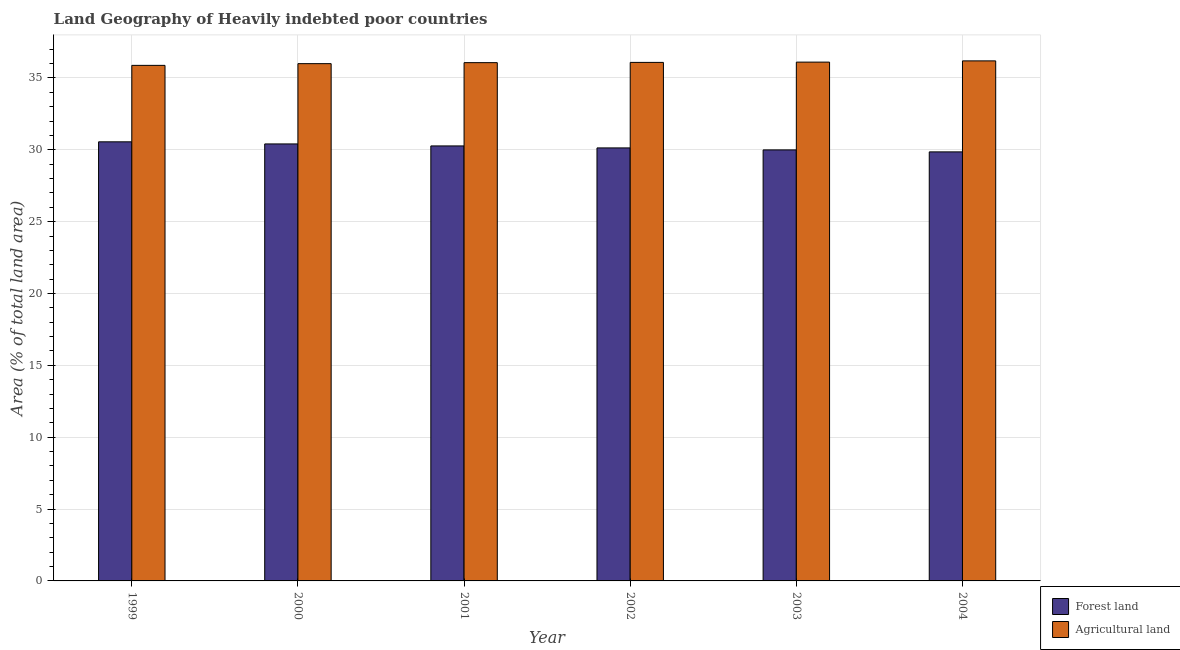How many groups of bars are there?
Keep it short and to the point. 6. Are the number of bars per tick equal to the number of legend labels?
Your answer should be compact. Yes. How many bars are there on the 2nd tick from the left?
Your answer should be very brief. 2. How many bars are there on the 5th tick from the right?
Provide a short and direct response. 2. What is the label of the 6th group of bars from the left?
Provide a succinct answer. 2004. In how many cases, is the number of bars for a given year not equal to the number of legend labels?
Provide a short and direct response. 0. What is the percentage of land area under forests in 2003?
Provide a succinct answer. 29.99. Across all years, what is the maximum percentage of land area under agriculture?
Provide a short and direct response. 36.19. Across all years, what is the minimum percentage of land area under agriculture?
Your answer should be compact. 35.87. In which year was the percentage of land area under agriculture maximum?
Ensure brevity in your answer.  2004. What is the total percentage of land area under agriculture in the graph?
Keep it short and to the point. 216.3. What is the difference between the percentage of land area under forests in 2000 and that in 2002?
Provide a succinct answer. 0.28. What is the difference between the percentage of land area under agriculture in 2001 and the percentage of land area under forests in 2000?
Make the answer very short. 0.07. What is the average percentage of land area under agriculture per year?
Make the answer very short. 36.05. In the year 2003, what is the difference between the percentage of land area under agriculture and percentage of land area under forests?
Your answer should be compact. 0. In how many years, is the percentage of land area under forests greater than 22 %?
Provide a succinct answer. 6. What is the ratio of the percentage of land area under forests in 2001 to that in 2002?
Ensure brevity in your answer.  1. Is the percentage of land area under agriculture in 1999 less than that in 2001?
Offer a terse response. Yes. Is the difference between the percentage of land area under agriculture in 2002 and 2003 greater than the difference between the percentage of land area under forests in 2002 and 2003?
Offer a very short reply. No. What is the difference between the highest and the second highest percentage of land area under forests?
Keep it short and to the point. 0.15. What is the difference between the highest and the lowest percentage of land area under forests?
Offer a very short reply. 0.7. In how many years, is the percentage of land area under agriculture greater than the average percentage of land area under agriculture taken over all years?
Keep it short and to the point. 4. Is the sum of the percentage of land area under agriculture in 1999 and 2002 greater than the maximum percentage of land area under forests across all years?
Provide a succinct answer. Yes. What does the 2nd bar from the left in 1999 represents?
Your answer should be very brief. Agricultural land. What does the 1st bar from the right in 1999 represents?
Offer a very short reply. Agricultural land. How many bars are there?
Make the answer very short. 12. Are all the bars in the graph horizontal?
Make the answer very short. No. What is the difference between two consecutive major ticks on the Y-axis?
Make the answer very short. 5. Are the values on the major ticks of Y-axis written in scientific E-notation?
Your response must be concise. No. What is the title of the graph?
Provide a succinct answer. Land Geography of Heavily indebted poor countries. What is the label or title of the X-axis?
Make the answer very short. Year. What is the label or title of the Y-axis?
Provide a short and direct response. Area (% of total land area). What is the Area (% of total land area) in Forest land in 1999?
Provide a short and direct response. 30.55. What is the Area (% of total land area) of Agricultural land in 1999?
Provide a short and direct response. 35.87. What is the Area (% of total land area) of Forest land in 2000?
Give a very brief answer. 30.41. What is the Area (% of total land area) in Agricultural land in 2000?
Offer a terse response. 35.99. What is the Area (% of total land area) of Forest land in 2001?
Provide a succinct answer. 30.27. What is the Area (% of total land area) in Agricultural land in 2001?
Keep it short and to the point. 36.06. What is the Area (% of total land area) in Forest land in 2002?
Offer a terse response. 30.13. What is the Area (% of total land area) in Agricultural land in 2002?
Your answer should be compact. 36.08. What is the Area (% of total land area) of Forest land in 2003?
Provide a succinct answer. 29.99. What is the Area (% of total land area) of Agricultural land in 2003?
Provide a succinct answer. 36.1. What is the Area (% of total land area) in Forest land in 2004?
Give a very brief answer. 29.85. What is the Area (% of total land area) in Agricultural land in 2004?
Your response must be concise. 36.19. Across all years, what is the maximum Area (% of total land area) in Forest land?
Keep it short and to the point. 30.55. Across all years, what is the maximum Area (% of total land area) in Agricultural land?
Keep it short and to the point. 36.19. Across all years, what is the minimum Area (% of total land area) in Forest land?
Your answer should be compact. 29.85. Across all years, what is the minimum Area (% of total land area) in Agricultural land?
Provide a succinct answer. 35.87. What is the total Area (% of total land area) in Forest land in the graph?
Offer a very short reply. 181.21. What is the total Area (% of total land area) in Agricultural land in the graph?
Your answer should be very brief. 216.3. What is the difference between the Area (% of total land area) in Forest land in 1999 and that in 2000?
Your response must be concise. 0.15. What is the difference between the Area (% of total land area) in Agricultural land in 1999 and that in 2000?
Offer a terse response. -0.12. What is the difference between the Area (% of total land area) of Forest land in 1999 and that in 2001?
Provide a succinct answer. 0.28. What is the difference between the Area (% of total land area) in Agricultural land in 1999 and that in 2001?
Give a very brief answer. -0.19. What is the difference between the Area (% of total land area) in Forest land in 1999 and that in 2002?
Your response must be concise. 0.42. What is the difference between the Area (% of total land area) in Agricultural land in 1999 and that in 2002?
Ensure brevity in your answer.  -0.21. What is the difference between the Area (% of total land area) of Forest land in 1999 and that in 2003?
Provide a succinct answer. 0.56. What is the difference between the Area (% of total land area) in Agricultural land in 1999 and that in 2003?
Provide a short and direct response. -0.23. What is the difference between the Area (% of total land area) of Forest land in 1999 and that in 2004?
Keep it short and to the point. 0.7. What is the difference between the Area (% of total land area) of Agricultural land in 1999 and that in 2004?
Keep it short and to the point. -0.31. What is the difference between the Area (% of total land area) of Forest land in 2000 and that in 2001?
Ensure brevity in your answer.  0.14. What is the difference between the Area (% of total land area) of Agricultural land in 2000 and that in 2001?
Keep it short and to the point. -0.07. What is the difference between the Area (% of total land area) in Forest land in 2000 and that in 2002?
Ensure brevity in your answer.  0.28. What is the difference between the Area (% of total land area) of Agricultural land in 2000 and that in 2002?
Offer a very short reply. -0.09. What is the difference between the Area (% of total land area) of Forest land in 2000 and that in 2003?
Keep it short and to the point. 0.41. What is the difference between the Area (% of total land area) of Agricultural land in 2000 and that in 2003?
Ensure brevity in your answer.  -0.11. What is the difference between the Area (% of total land area) in Forest land in 2000 and that in 2004?
Offer a terse response. 0.55. What is the difference between the Area (% of total land area) in Agricultural land in 2000 and that in 2004?
Keep it short and to the point. -0.19. What is the difference between the Area (% of total land area) of Forest land in 2001 and that in 2002?
Give a very brief answer. 0.14. What is the difference between the Area (% of total land area) in Agricultural land in 2001 and that in 2002?
Ensure brevity in your answer.  -0.02. What is the difference between the Area (% of total land area) in Forest land in 2001 and that in 2003?
Keep it short and to the point. 0.28. What is the difference between the Area (% of total land area) of Agricultural land in 2001 and that in 2003?
Offer a very short reply. -0.04. What is the difference between the Area (% of total land area) in Forest land in 2001 and that in 2004?
Provide a short and direct response. 0.41. What is the difference between the Area (% of total land area) in Agricultural land in 2001 and that in 2004?
Offer a very short reply. -0.12. What is the difference between the Area (% of total land area) in Forest land in 2002 and that in 2003?
Make the answer very short. 0.14. What is the difference between the Area (% of total land area) of Agricultural land in 2002 and that in 2003?
Your answer should be very brief. -0.02. What is the difference between the Area (% of total land area) in Forest land in 2002 and that in 2004?
Ensure brevity in your answer.  0.28. What is the difference between the Area (% of total land area) of Agricultural land in 2002 and that in 2004?
Make the answer very short. -0.11. What is the difference between the Area (% of total land area) in Forest land in 2003 and that in 2004?
Offer a terse response. 0.14. What is the difference between the Area (% of total land area) in Agricultural land in 2003 and that in 2004?
Your answer should be very brief. -0.09. What is the difference between the Area (% of total land area) in Forest land in 1999 and the Area (% of total land area) in Agricultural land in 2000?
Your answer should be compact. -5.44. What is the difference between the Area (% of total land area) in Forest land in 1999 and the Area (% of total land area) in Agricultural land in 2001?
Provide a short and direct response. -5.51. What is the difference between the Area (% of total land area) in Forest land in 1999 and the Area (% of total land area) in Agricultural land in 2002?
Offer a terse response. -5.53. What is the difference between the Area (% of total land area) in Forest land in 1999 and the Area (% of total land area) in Agricultural land in 2003?
Your answer should be compact. -5.55. What is the difference between the Area (% of total land area) in Forest land in 1999 and the Area (% of total land area) in Agricultural land in 2004?
Provide a short and direct response. -5.63. What is the difference between the Area (% of total land area) of Forest land in 2000 and the Area (% of total land area) of Agricultural land in 2001?
Make the answer very short. -5.66. What is the difference between the Area (% of total land area) in Forest land in 2000 and the Area (% of total land area) in Agricultural land in 2002?
Provide a succinct answer. -5.67. What is the difference between the Area (% of total land area) in Forest land in 2000 and the Area (% of total land area) in Agricultural land in 2003?
Your answer should be compact. -5.69. What is the difference between the Area (% of total land area) in Forest land in 2000 and the Area (% of total land area) in Agricultural land in 2004?
Ensure brevity in your answer.  -5.78. What is the difference between the Area (% of total land area) of Forest land in 2001 and the Area (% of total land area) of Agricultural land in 2002?
Offer a very short reply. -5.81. What is the difference between the Area (% of total land area) of Forest land in 2001 and the Area (% of total land area) of Agricultural land in 2003?
Give a very brief answer. -5.83. What is the difference between the Area (% of total land area) of Forest land in 2001 and the Area (% of total land area) of Agricultural land in 2004?
Provide a short and direct response. -5.92. What is the difference between the Area (% of total land area) in Forest land in 2002 and the Area (% of total land area) in Agricultural land in 2003?
Your response must be concise. -5.97. What is the difference between the Area (% of total land area) of Forest land in 2002 and the Area (% of total land area) of Agricultural land in 2004?
Offer a very short reply. -6.06. What is the difference between the Area (% of total land area) in Forest land in 2003 and the Area (% of total land area) in Agricultural land in 2004?
Keep it short and to the point. -6.19. What is the average Area (% of total land area) of Forest land per year?
Make the answer very short. 30.2. What is the average Area (% of total land area) in Agricultural land per year?
Offer a terse response. 36.05. In the year 1999, what is the difference between the Area (% of total land area) in Forest land and Area (% of total land area) in Agricultural land?
Your answer should be compact. -5.32. In the year 2000, what is the difference between the Area (% of total land area) of Forest land and Area (% of total land area) of Agricultural land?
Your response must be concise. -5.59. In the year 2001, what is the difference between the Area (% of total land area) in Forest land and Area (% of total land area) in Agricultural land?
Your response must be concise. -5.79. In the year 2002, what is the difference between the Area (% of total land area) in Forest land and Area (% of total land area) in Agricultural land?
Your answer should be compact. -5.95. In the year 2003, what is the difference between the Area (% of total land area) in Forest land and Area (% of total land area) in Agricultural land?
Your answer should be compact. -6.11. In the year 2004, what is the difference between the Area (% of total land area) of Forest land and Area (% of total land area) of Agricultural land?
Offer a terse response. -6.33. What is the ratio of the Area (% of total land area) of Agricultural land in 1999 to that in 2000?
Offer a terse response. 1. What is the ratio of the Area (% of total land area) in Forest land in 1999 to that in 2001?
Offer a terse response. 1.01. What is the ratio of the Area (% of total land area) of Agricultural land in 1999 to that in 2001?
Offer a terse response. 0.99. What is the ratio of the Area (% of total land area) of Forest land in 1999 to that in 2002?
Your answer should be very brief. 1.01. What is the ratio of the Area (% of total land area) of Agricultural land in 1999 to that in 2002?
Your response must be concise. 0.99. What is the ratio of the Area (% of total land area) of Forest land in 1999 to that in 2003?
Provide a succinct answer. 1.02. What is the ratio of the Area (% of total land area) in Agricultural land in 1999 to that in 2003?
Provide a succinct answer. 0.99. What is the ratio of the Area (% of total land area) in Forest land in 1999 to that in 2004?
Make the answer very short. 1.02. What is the ratio of the Area (% of total land area) in Forest land in 2000 to that in 2001?
Keep it short and to the point. 1. What is the ratio of the Area (% of total land area) of Forest land in 2000 to that in 2002?
Ensure brevity in your answer.  1.01. What is the ratio of the Area (% of total land area) in Forest land in 2000 to that in 2003?
Give a very brief answer. 1.01. What is the ratio of the Area (% of total land area) in Forest land in 2000 to that in 2004?
Provide a short and direct response. 1.02. What is the ratio of the Area (% of total land area) of Agricultural land in 2000 to that in 2004?
Provide a succinct answer. 0.99. What is the ratio of the Area (% of total land area) in Agricultural land in 2001 to that in 2002?
Ensure brevity in your answer.  1. What is the ratio of the Area (% of total land area) in Forest land in 2001 to that in 2003?
Keep it short and to the point. 1.01. What is the ratio of the Area (% of total land area) in Agricultural land in 2001 to that in 2003?
Offer a very short reply. 1. What is the ratio of the Area (% of total land area) of Forest land in 2001 to that in 2004?
Offer a terse response. 1.01. What is the ratio of the Area (% of total land area) of Agricultural land in 2001 to that in 2004?
Your response must be concise. 1. What is the ratio of the Area (% of total land area) of Agricultural land in 2002 to that in 2003?
Ensure brevity in your answer.  1. What is the ratio of the Area (% of total land area) of Forest land in 2002 to that in 2004?
Provide a succinct answer. 1.01. What is the ratio of the Area (% of total land area) in Agricultural land in 2002 to that in 2004?
Provide a succinct answer. 1. What is the difference between the highest and the second highest Area (% of total land area) in Forest land?
Make the answer very short. 0.15. What is the difference between the highest and the second highest Area (% of total land area) in Agricultural land?
Provide a short and direct response. 0.09. What is the difference between the highest and the lowest Area (% of total land area) of Forest land?
Offer a terse response. 0.7. What is the difference between the highest and the lowest Area (% of total land area) in Agricultural land?
Keep it short and to the point. 0.31. 